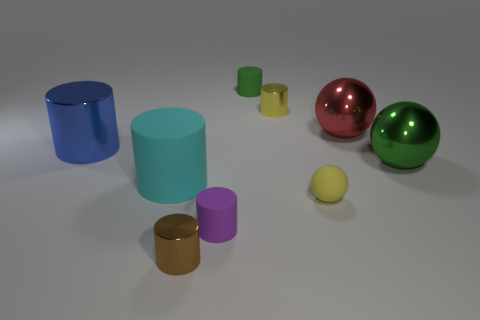Do the rubber sphere and the big rubber cylinder have the same color?
Provide a short and direct response. No. Are there any other metal things that have the same shape as the big blue metallic object?
Your response must be concise. Yes. There is a matte cylinder that is the same size as the green metal object; what is its color?
Provide a short and direct response. Cyan. What number of things are either small purple objects that are in front of the green matte thing or things that are on the left side of the red metal ball?
Make the answer very short. 7. How many objects are either purple things or yellow shiny objects?
Your answer should be very brief. 2. There is a rubber cylinder that is in front of the tiny yellow cylinder and on the right side of the brown shiny thing; what is its size?
Provide a succinct answer. Small. How many big cyan cylinders are made of the same material as the tiny yellow cylinder?
Provide a succinct answer. 0. There is a large object that is the same material as the purple cylinder; what color is it?
Your answer should be very brief. Cyan. Is the color of the tiny shiny cylinder behind the large red metallic ball the same as the small sphere?
Your answer should be compact. Yes. What is the material of the tiny yellow ball behind the brown metal object?
Offer a very short reply. Rubber. 